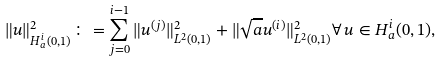<formula> <loc_0><loc_0><loc_500><loc_500>\| u \| ^ { 2 } _ { H ^ { i } _ { a } ( 0 , 1 ) } \colon = \sum _ { j = 0 } ^ { i - 1 } \| u ^ { ( j ) } \| ^ { 2 } _ { L ^ { 2 } ( 0 , 1 ) } + \| \sqrt { a } u ^ { ( i ) } \| ^ { 2 } _ { L ^ { 2 } ( 0 , 1 ) } \forall \, u \in H ^ { i } _ { a } ( 0 , 1 ) ,</formula> 